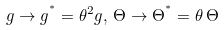Convert formula to latex. <formula><loc_0><loc_0><loc_500><loc_500>g \rightarrow g ^ { ^ { * } } = \theta ^ { 2 } g , \, \Theta \rightarrow \Theta ^ { ^ { * } } = \theta \, \Theta</formula> 